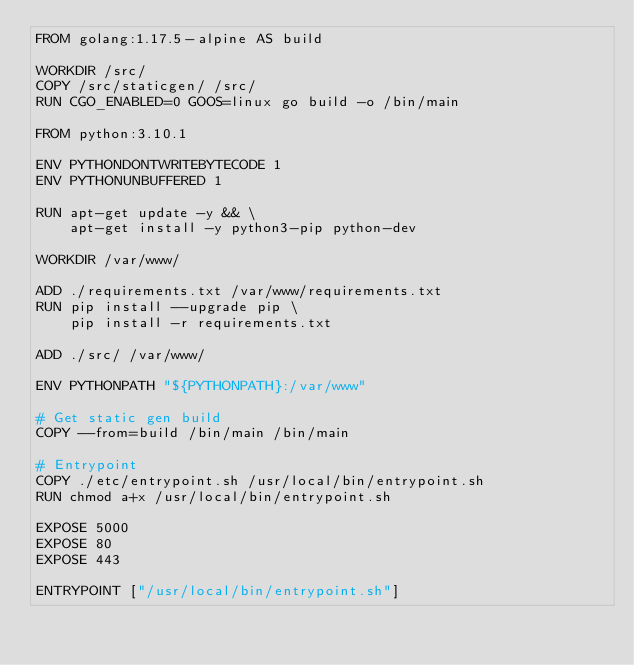Convert code to text. <code><loc_0><loc_0><loc_500><loc_500><_Dockerfile_>FROM golang:1.17.5-alpine AS build

WORKDIR /src/
COPY /src/staticgen/ /src/
RUN CGO_ENABLED=0 GOOS=linux go build -o /bin/main

FROM python:3.10.1

ENV PYTHONDONTWRITEBYTECODE 1
ENV PYTHONUNBUFFERED 1

RUN apt-get update -y && \
    apt-get install -y python3-pip python-dev

WORKDIR /var/www/

ADD ./requirements.txt /var/www/requirements.txt
RUN pip install --upgrade pip \
    pip install -r requirements.txt

ADD ./src/ /var/www/

ENV PYTHONPATH "${PYTHONPATH}:/var/www"

# Get static gen build
COPY --from=build /bin/main /bin/main

# Entrypoint
COPY ./etc/entrypoint.sh /usr/local/bin/entrypoint.sh
RUN chmod a+x /usr/local/bin/entrypoint.sh

EXPOSE 5000
EXPOSE 80
EXPOSE 443

ENTRYPOINT ["/usr/local/bin/entrypoint.sh"]
</code> 